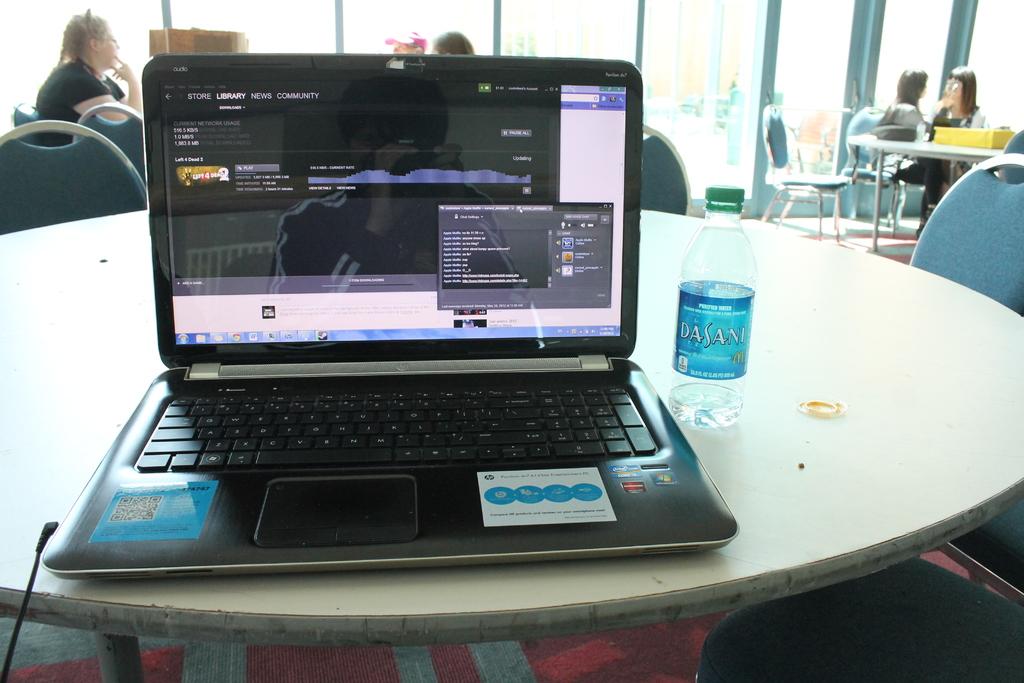What brand of water is on the table?
Give a very brief answer. Dasani. What tab is highlighted on the screen, in the upper left corner?
Make the answer very short. Library. 